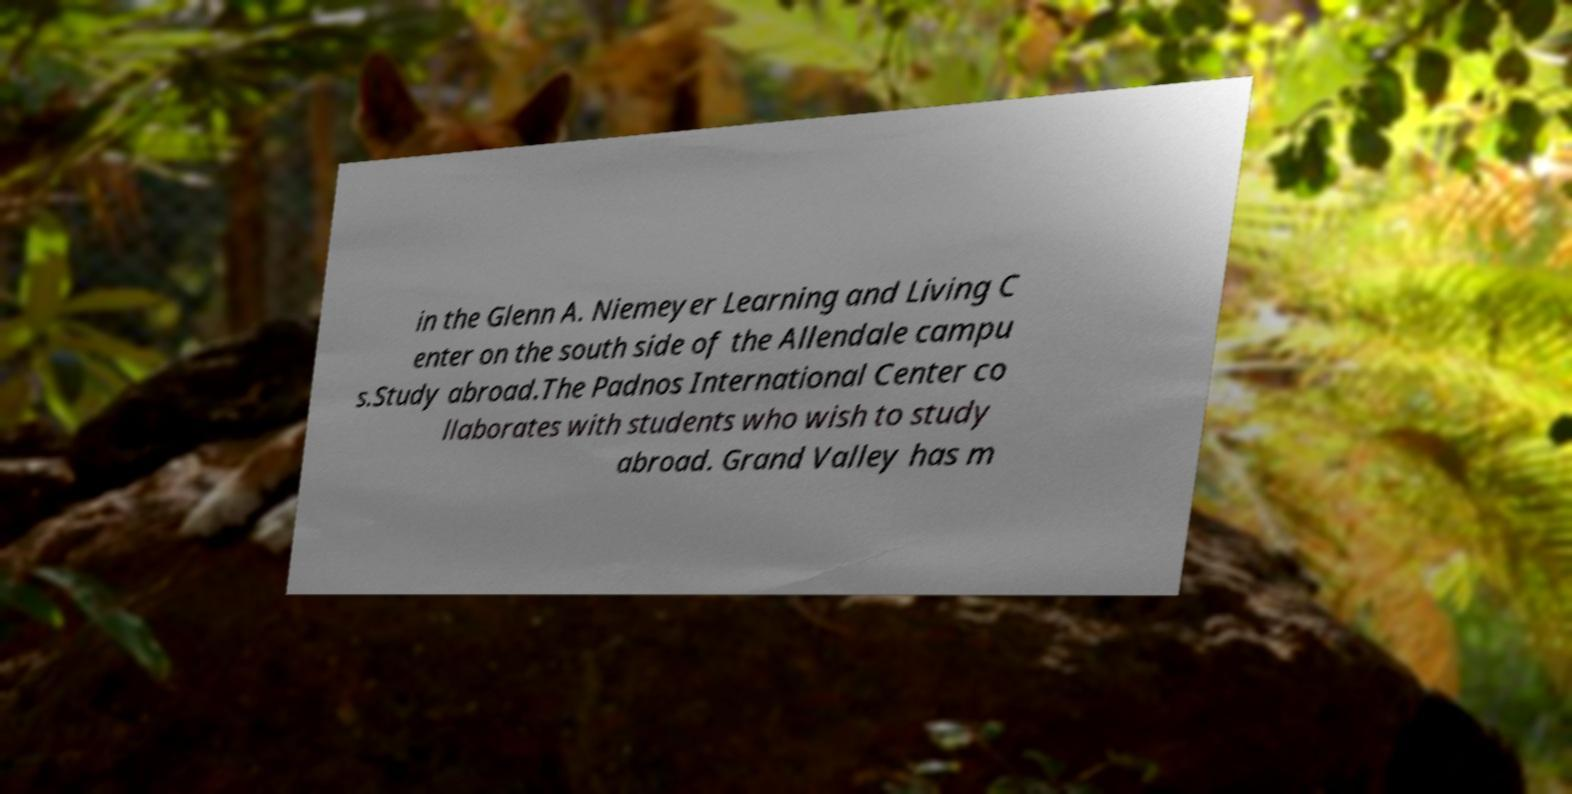There's text embedded in this image that I need extracted. Can you transcribe it verbatim? in the Glenn A. Niemeyer Learning and Living C enter on the south side of the Allendale campu s.Study abroad.The Padnos International Center co llaborates with students who wish to study abroad. Grand Valley has m 